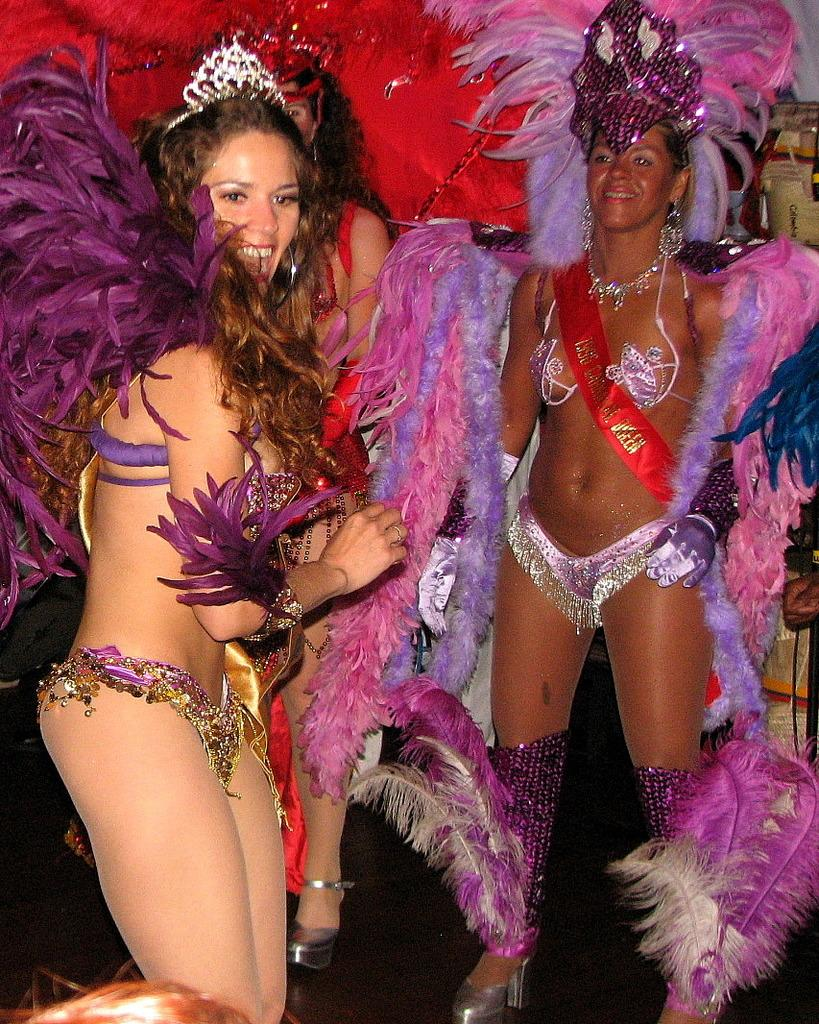How many people are in the image? There are three persons in the image. What are the persons wearing? The persons are wearing fancy dresses. What is unique about the fancy dresses? The fancy dresses are decorated with feathers. What scientific discovery did the persons make while wearing the fancy dresses in the image? There is no indication in the image that the persons made any scientific discovery while wearing the fancy dresses. 